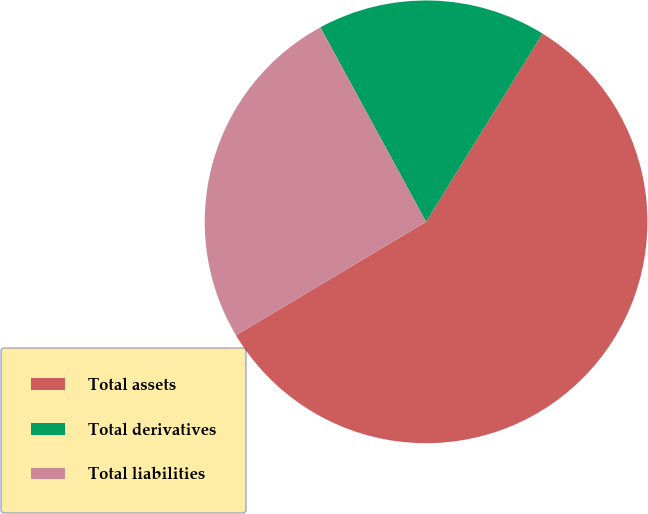<chart> <loc_0><loc_0><loc_500><loc_500><pie_chart><fcel>Total assets<fcel>Total derivatives<fcel>Total liabilities<nl><fcel>57.62%<fcel>16.74%<fcel>25.64%<nl></chart> 